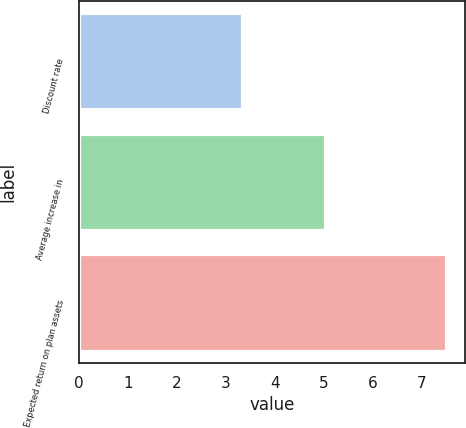<chart> <loc_0><loc_0><loc_500><loc_500><bar_chart><fcel>Discount rate<fcel>Average increase in<fcel>Expected return on plan assets<nl><fcel>3.33<fcel>5.02<fcel>7.5<nl></chart> 